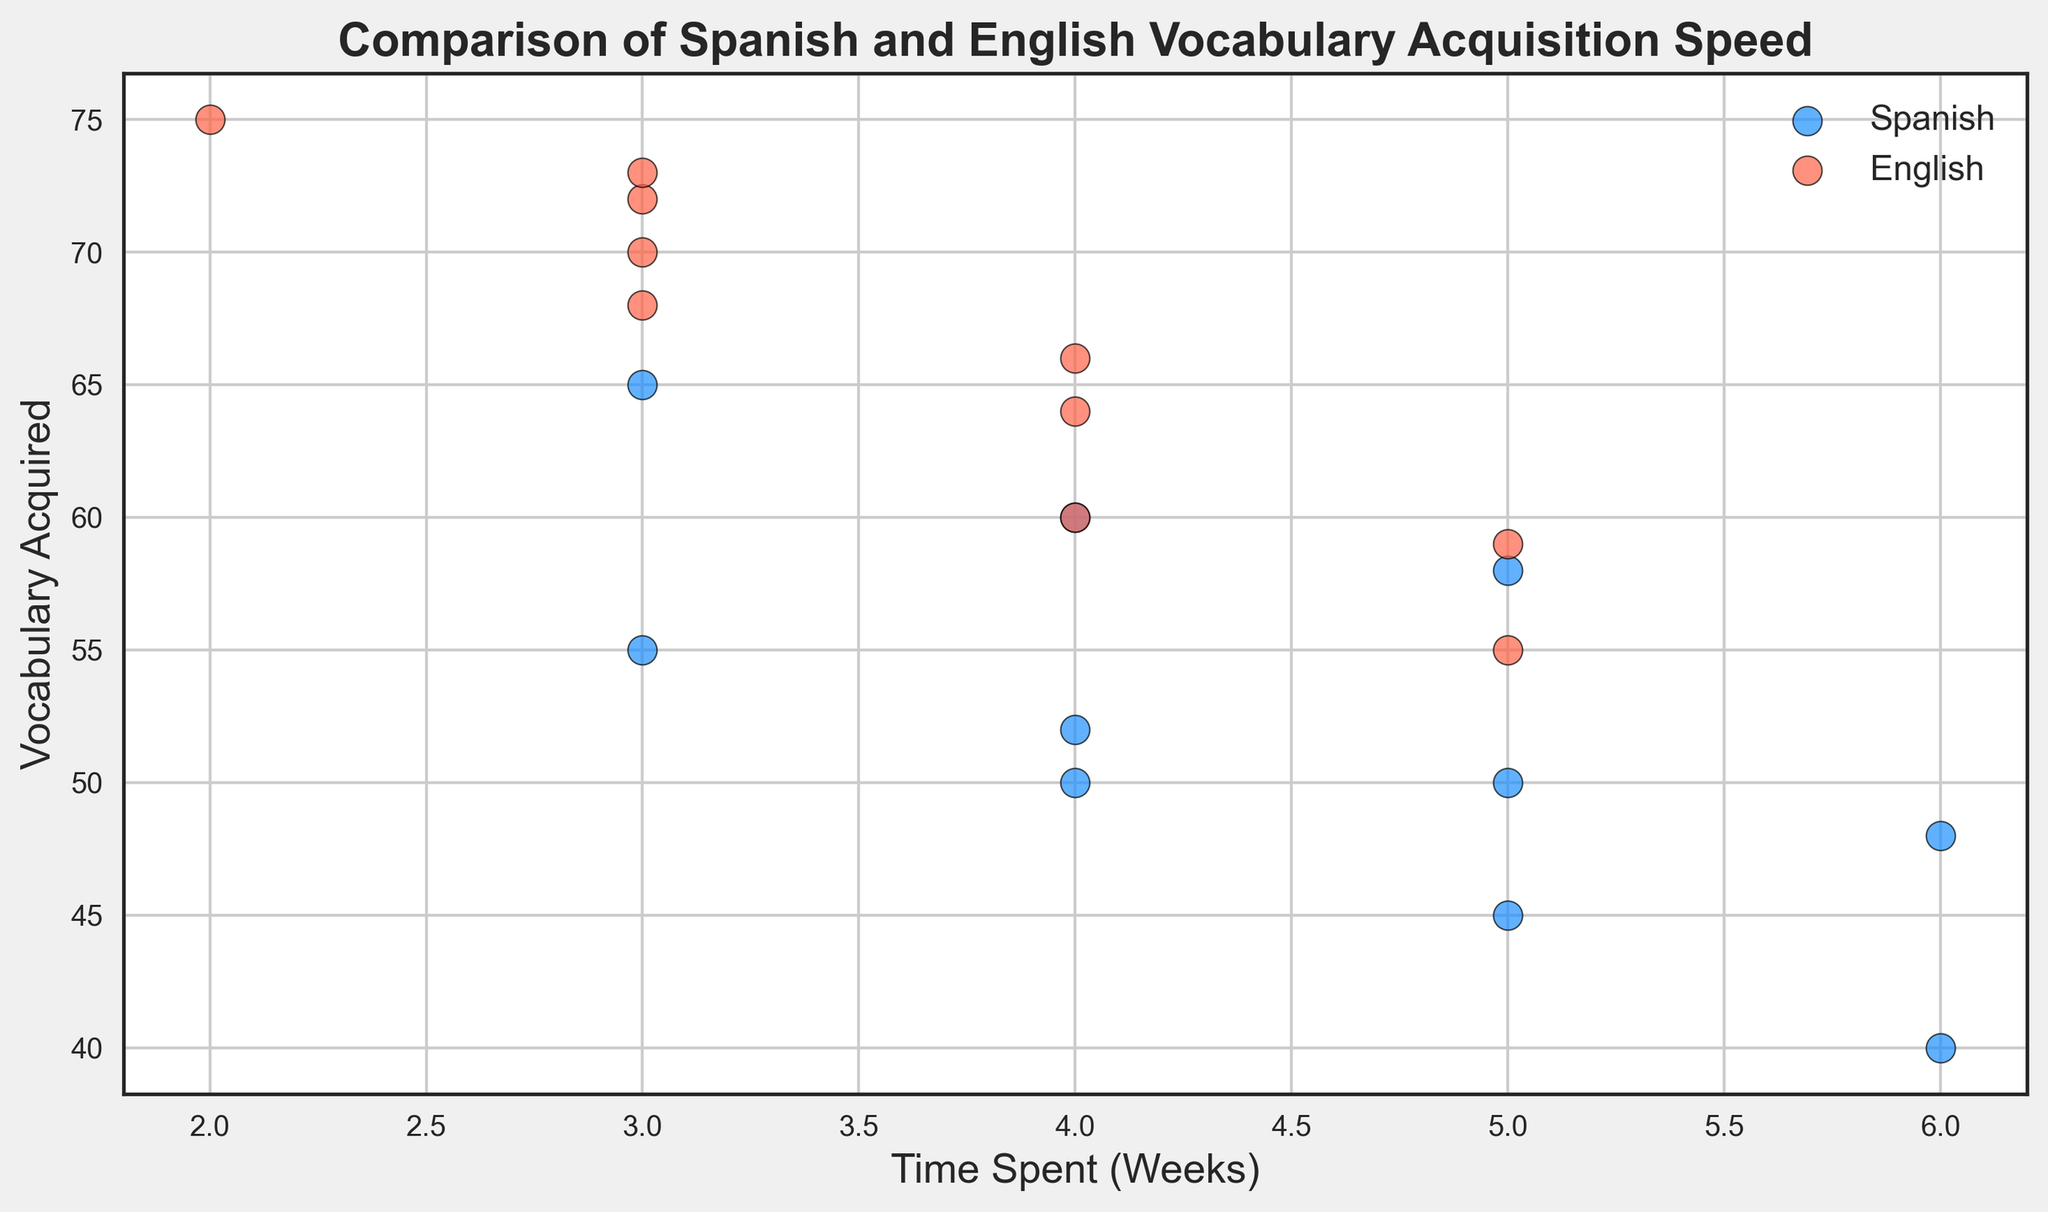What's the average vocabulary acquired by students studying Spanish? Add up the vocabulary acquired by all Spanish students (50 + 45 + 55 + 40 + 60 + 50 + 65 + 48 + 52 + 58) = 523. Then divide by the number of Spanish students, which is 10. So, 523/10 = 52.3.
Answer: 52.3 Which language group exhibits a higher rate of vocabulary acquisition overall? Visual examination of the scatter plot indicates that the English group generally has higher vocabulary acquisition for similar or fewer weeks of time spent compared to the Spanish group. This suggests a higher rate for English.
Answer: English What is the highest number of vocabulary words acquired by any student? From the scatter plot, observe the highest value on the vocabulary-acquired axis. The highest number noted is 75, corresponding to an English student.
Answer: 75 How many students spent exactly 4 weeks studying English? Count the number of red points (representing English students) that are positioned at the 4 weeks mark on the x-axis. There are three such points.
Answer: 3 Is there a student who acquired more than 60 words in less than 4 weeks in the Spanish group? Look at the blue points on the scatter plot for the Spanish group and identify any above 60 vocabulary acquired within less than 4 weeks on the x-axis. None of the blue points meet this criterion.
Answer: No What is the difference in vocabulary acquired between the English and Spanish groups at the 5-week mark? Identify values for vocabulary acquired by both groups at 5 weeks. The Spanish group has two relevant points at 45 and 50 (average 47.5), and the English group has values at 55 and 59 (average 57). The difference is 57 - 47.5 = 9.5.
Answer: 9.5 Which language group has the student with the fastest vocabulary acquisition rate (words per week)? Calculate the rate for each highest-achieving student in each group. For English: 75 words / 2 weeks = 37.5 words/week. For Spanish: 65 words / 3 weeks = ~21.67 words/week. English student is faster.
Answer: English Are there more students who acquired vocabulary words in 3 weeks in the Spanish or English group? Count the number of points at the 3-week mark for both groups. Spanish has 2 students (55 and 65 words), English has 4 students (68, 70, 72, and 73 words). English has more students.
Answer: English Do Spanish students tend to spend more time acquiring vocabulary compared to English students? Compare the distribution of points along the x-axis (time spent) between the blue (Spanish) and red (English) points. The Spanish points are more spread out over a longer period, indicating they spend more time on average.
Answer: Yes 